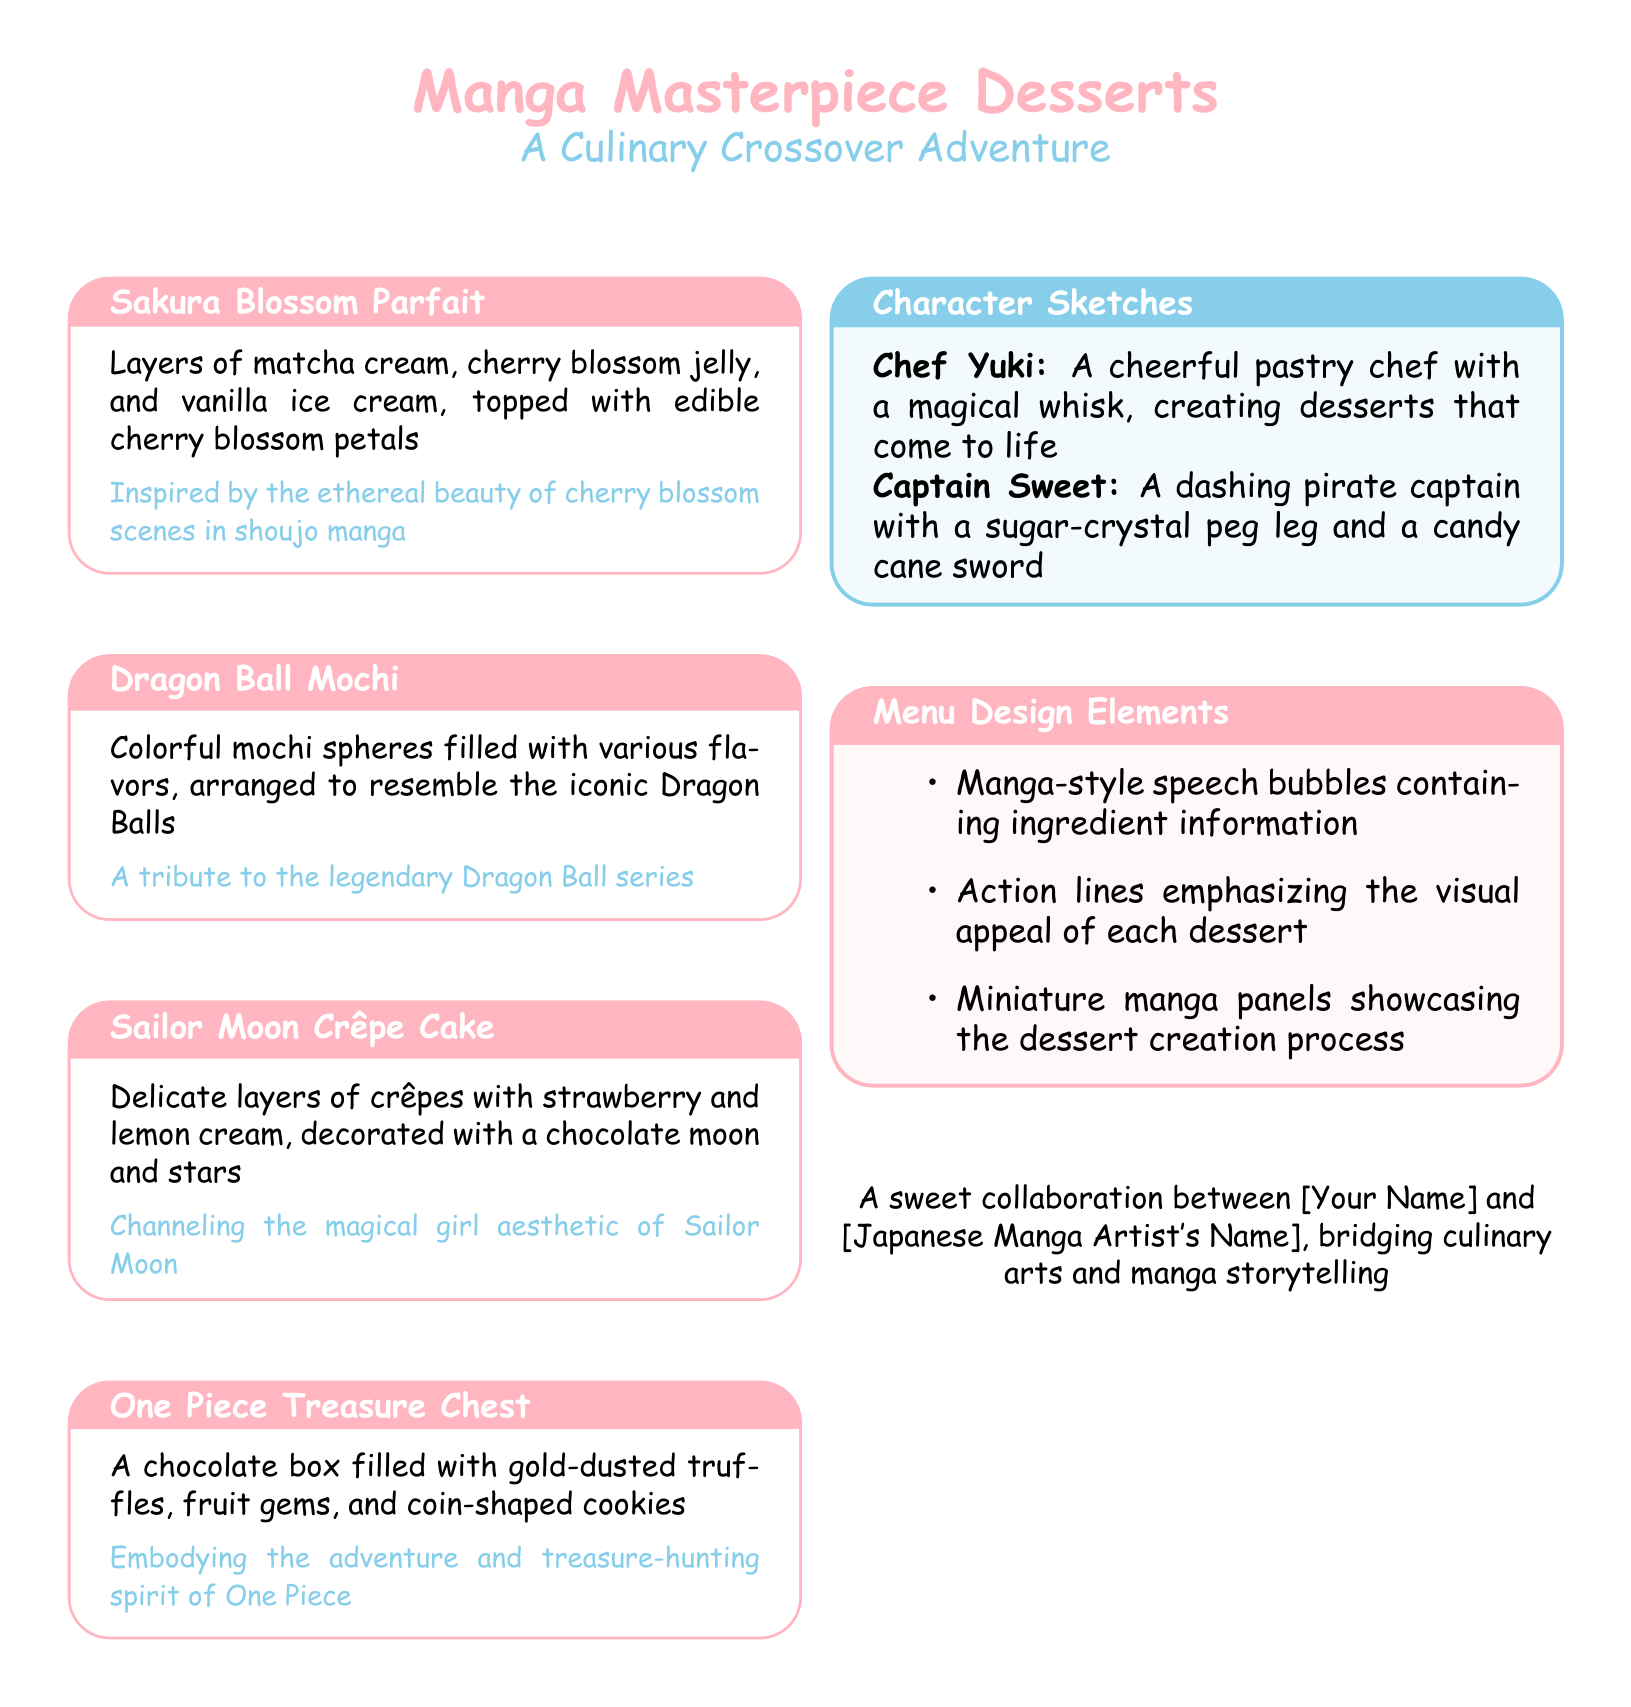What is the title of the menu? The title of the menu is prominently displayed at the top of the document, which is "Manga Masterpiece Desserts."
Answer: Manga Masterpiece Desserts How many dessert items are listed on the menu? The document showcases four dessert items under separate tcolorboxes.
Answer: 4 What is the main ingredient in the Sakura Blossom Parfait? The description of the dessert specifies that it includes matcha cream and cherry blossom jelly.
Answer: Matcha cream What character is depicted as Chef Yuki? The document introduces a character named Chef Yuki with a magical whisk.
Answer: Chef Yuki Which dessert is inspired by One Piece? The text states that the "One Piece Treasure Chest" embodies the adventure and treasure-hunting spirit of the series.
Answer: One Piece Treasure Chest How are the dessert creations visually represented in the menu? The document lists several design elements, including manga-style speech bubbles and action lines.
Answer: Manga-style speech bubbles What is unique about Captain Sweet's appearance? Captain Sweet's description includes a sugar-crystal peg leg and a candy cane sword.
Answer: Sugar-crystal peg leg What is included in the One Piece Treasure Chest dessert? The document reveals that it contains gold-dusted truffles, fruit gems, and coin-shaped cookies.
Answer: Gold-dusted truffles What type of aesthetic does the Sailor Moon Crêpe Cake channel? The dessert's description refers to it as channeling the magical girl aesthetic.
Answer: Magical girl aesthetic 